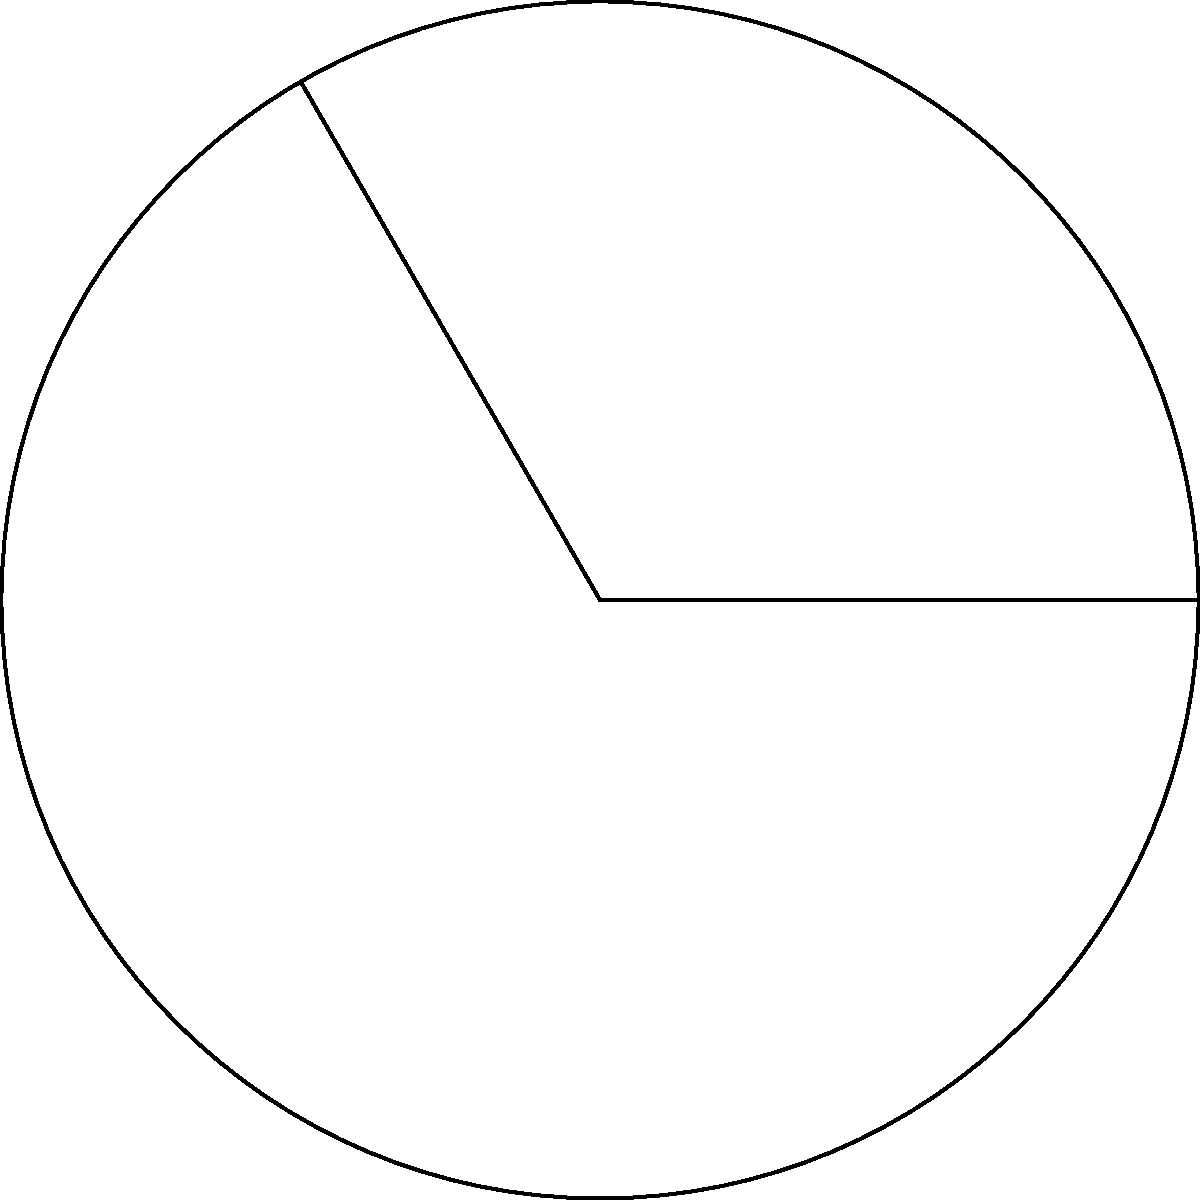As a personal trainer, you're designing a circular running track for a client who wants to maintain privacy. The track has a radius of 3 meters, and you want to mark a specific section for interval training. If the central angle of this section is 120°, what is the length of the arc that represents this interval training section? To find the length of an arc, we can use the formula:

$$ \text{Arc Length} = \frac{\theta}{360°} \cdot 2\pi r $$

Where:
- $\theta$ is the central angle in degrees
- $r$ is the radius of the circle

Given:
- Central angle $\theta = 120°$
- Radius $r = 3$ meters

Let's substitute these values into the formula:

$$ \text{Arc Length} = \frac{120°}{360°} \cdot 2\pi \cdot 3 $$

Simplifying:
$$ \text{Arc Length} = \frac{1}{3} \cdot 2\pi \cdot 3 = 2\pi \text{ meters} $$

We can leave the answer as $2\pi$ meters or calculate the approximate value:

$$ 2\pi \approx 2 \cdot 3.14159 \approx 6.28318 \text{ meters} $$
Answer: $2\pi$ meters (or approximately 6.28 meters) 